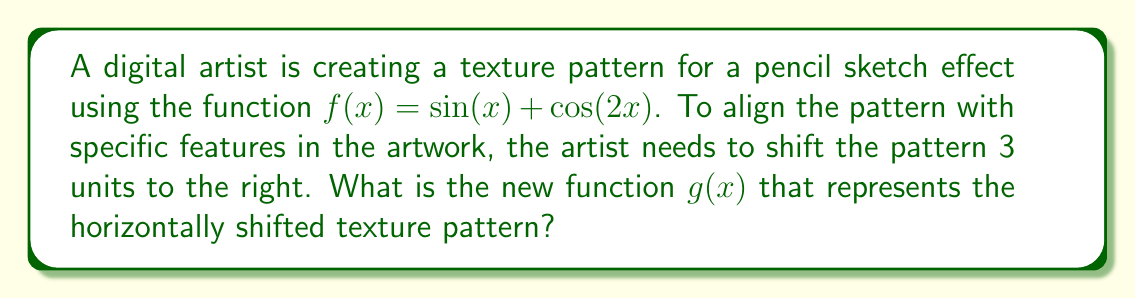Give your solution to this math problem. To horizontally shift a function to the right, we subtract the shift amount from the input variable. Here's how we do it step-by-step:

1. The original function is $f(x) = \sin(x) + \cos(2x)$

2. To shift 3 units to the right, we replace every $x$ with $(x - 3)$:
   $g(x) = \sin(x - 3) + \cos(2(x - 3))$

3. Simplify the argument of the cosine function:
   $g(x) = \sin(x - 3) + \cos(2x - 6)$

This new function $g(x)$ represents the texture pattern shifted 3 units to the right, which allows the digital artist to align the pattern with specific features in their pencil sketch-inspired artwork.
Answer: $g(x) = \sin(x - 3) + \cos(2x - 6)$ 